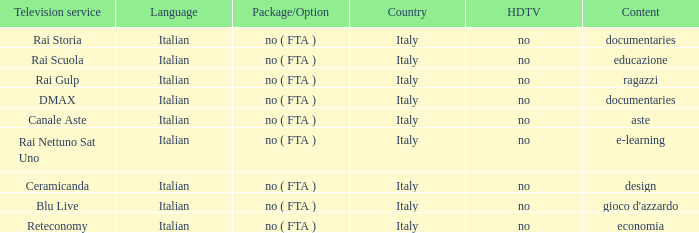What is the HDTV for the Rai Nettuno Sat Uno Television service? No. 